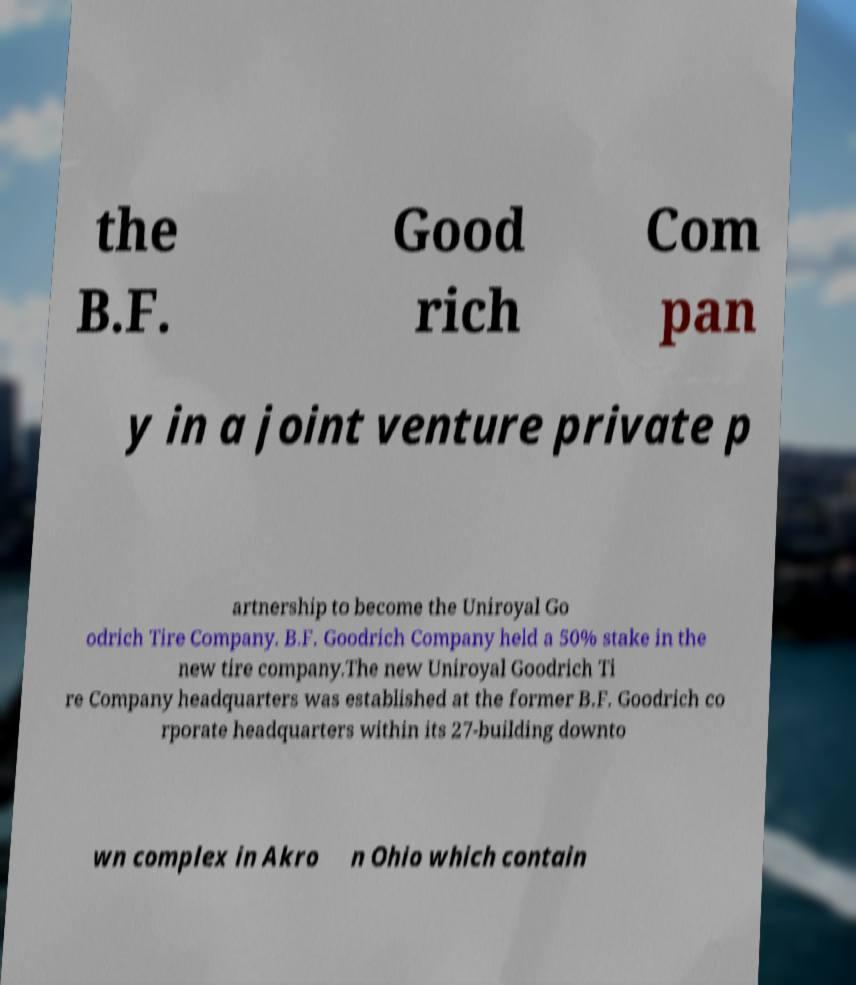Could you assist in decoding the text presented in this image and type it out clearly? the B.F. Good rich Com pan y in a joint venture private p artnership to become the Uniroyal Go odrich Tire Company. B.F. Goodrich Company held a 50% stake in the new tire company.The new Uniroyal Goodrich Ti re Company headquarters was established at the former B.F. Goodrich co rporate headquarters within its 27-building downto wn complex in Akro n Ohio which contain 